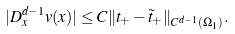Convert formula to latex. <formula><loc_0><loc_0><loc_500><loc_500>| D _ { x } ^ { d - 1 } v ( x ) | \leq C \| t _ { + } - \tilde { t } _ { + } \| _ { C ^ { d - 1 } ( \Omega _ { 1 } ) } .</formula> 